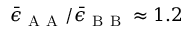<formula> <loc_0><loc_0><loc_500><loc_500>\bar { \epsilon } _ { A A } / \bar { \epsilon } _ { B B } \approx 1 . 2</formula> 